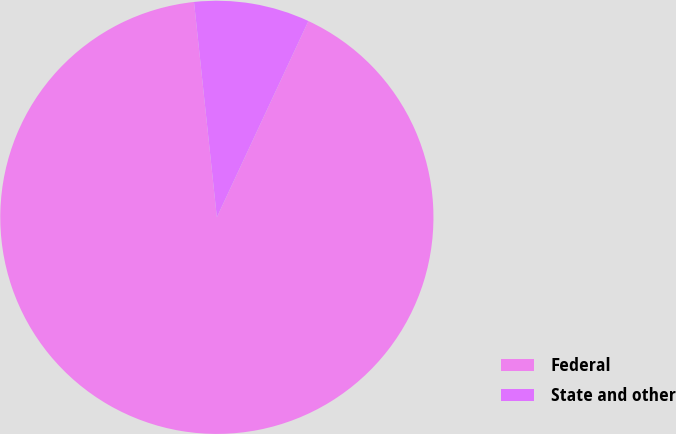Convert chart. <chart><loc_0><loc_0><loc_500><loc_500><pie_chart><fcel>Federal<fcel>State and other<nl><fcel>91.37%<fcel>8.63%<nl></chart> 